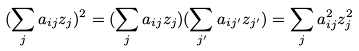<formula> <loc_0><loc_0><loc_500><loc_500>( \sum _ { j } a _ { i j } z _ { j } ) ^ { 2 } = ( \sum _ { j } a _ { i j } z _ { j } ) ( \sum _ { j ^ { \prime } } a _ { i j ^ { \prime } } z _ { j ^ { \prime } } ) = \sum _ { j } a _ { i j } ^ { 2 } z _ { j } ^ { 2 }</formula> 